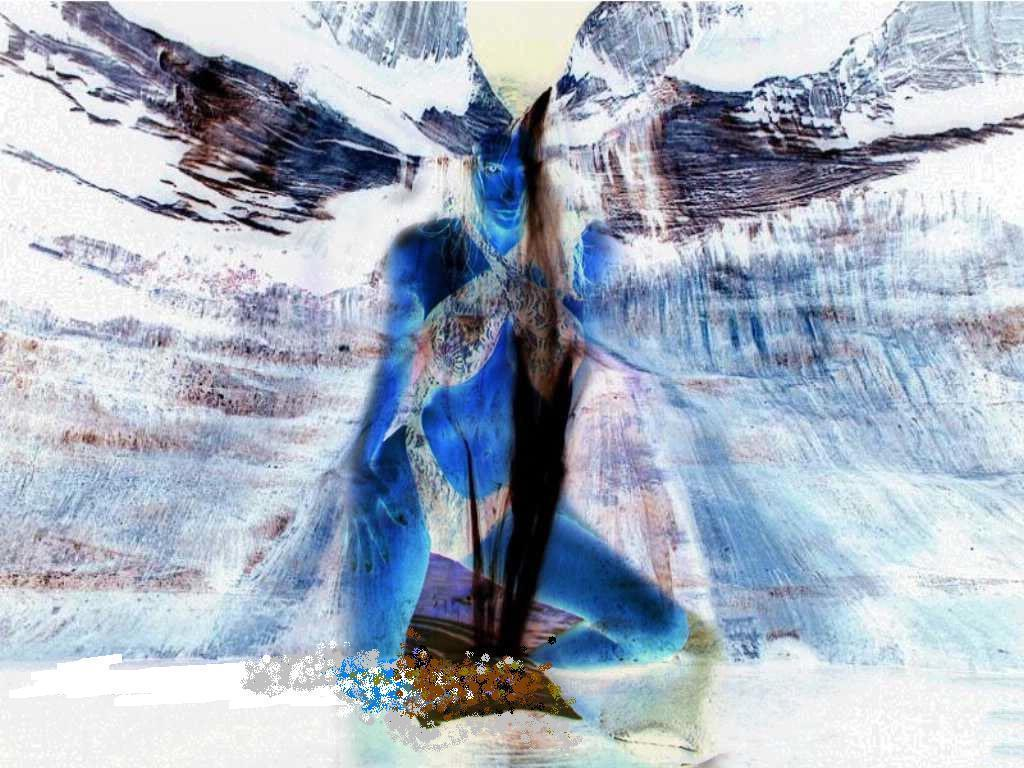What is the main subject of the image? The main subject of the image is a woman. Can you describe the representation of the woman in the image? The image is a graphical representation of a woman, which means it is likely a drawing, painting, or digital illustration. How many sheep are present in the image? There are no sheep present in the image; it is a graphical representation of a woman. What type of record can be seen being played in the image? There is no record or any indication of music playing in the image; it is a graphical representation of a woman. 